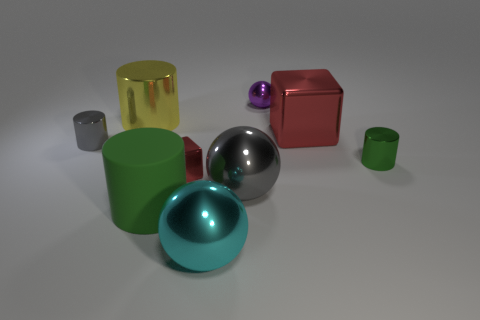Is there anything else that is the same material as the large green thing?
Offer a very short reply. No. There is a object that is the same color as the matte cylinder; what is its material?
Ensure brevity in your answer.  Metal. How many blocks have the same color as the small sphere?
Your answer should be compact. 0. What size is the matte cylinder?
Your answer should be very brief. Large. There is a small green thing; is its shape the same as the large thing that is behind the big red metal object?
Provide a succinct answer. Yes. What color is the big cube that is the same material as the purple ball?
Your response must be concise. Red. There is a green thing that is behind the tiny red cube; what is its size?
Offer a very short reply. Small. Is the number of yellow metal cylinders right of the gray shiny ball less than the number of big red spheres?
Ensure brevity in your answer.  No. Is the large metal cylinder the same color as the small shiny block?
Keep it short and to the point. No. Is there anything else that is the same shape as the large gray object?
Ensure brevity in your answer.  Yes. 